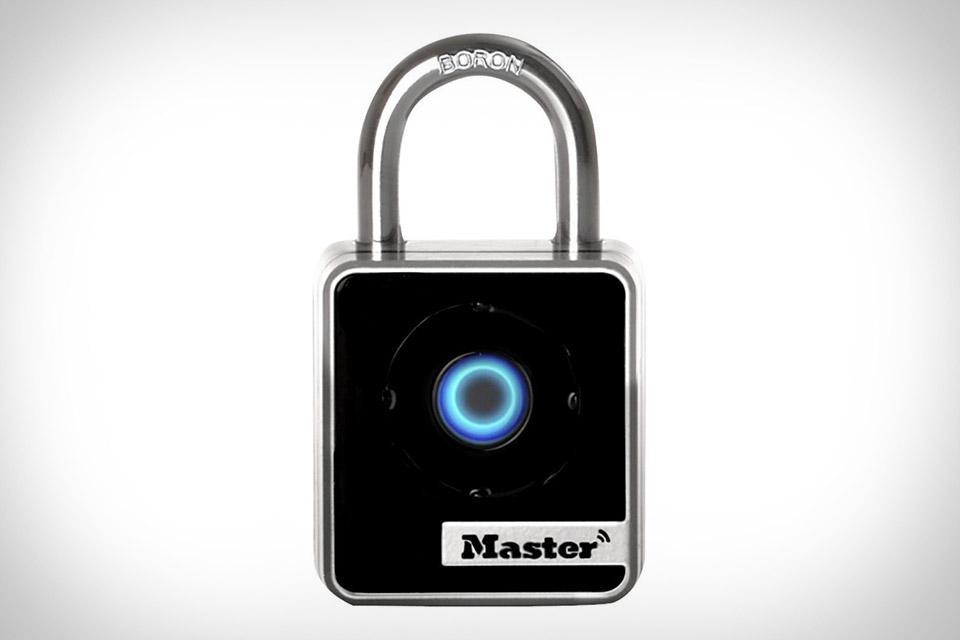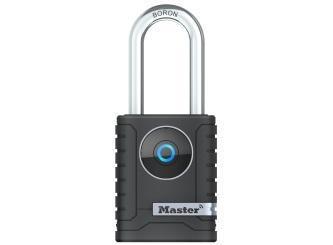The first image is the image on the left, the second image is the image on the right. Assess this claim about the two images: "There are two locks.". Correct or not? Answer yes or no. Yes. The first image is the image on the left, the second image is the image on the right. Analyze the images presented: Is the assertion "There are at least three padlocks." valid? Answer yes or no. No. 